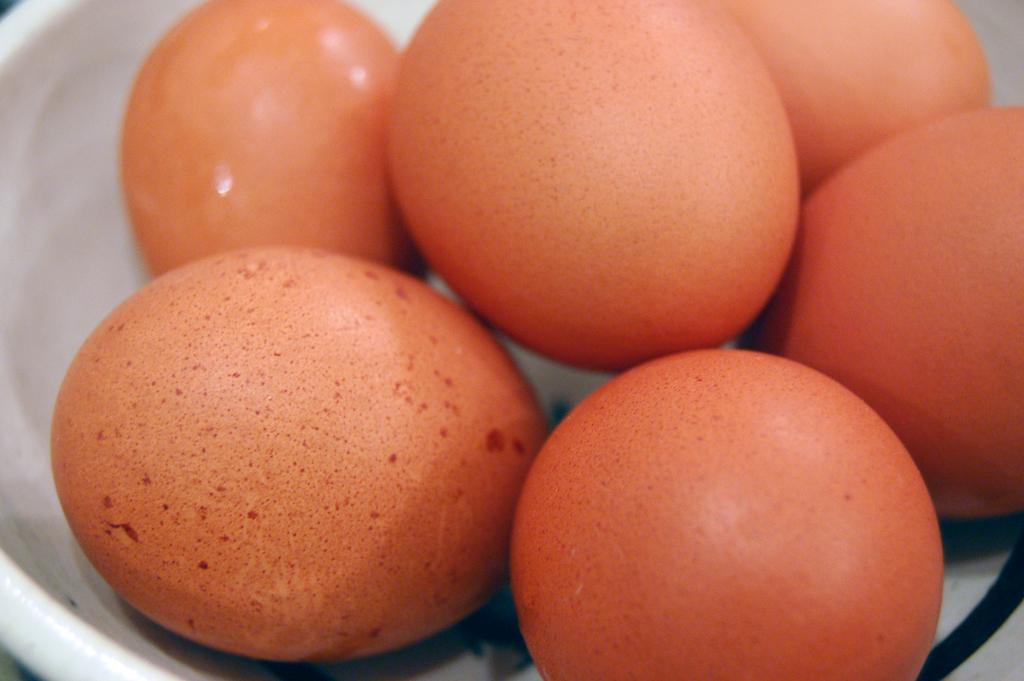How would you summarize this image in a sentence or two? In the picture I can see few eggs which are in orange color are placed in a white bowl. 